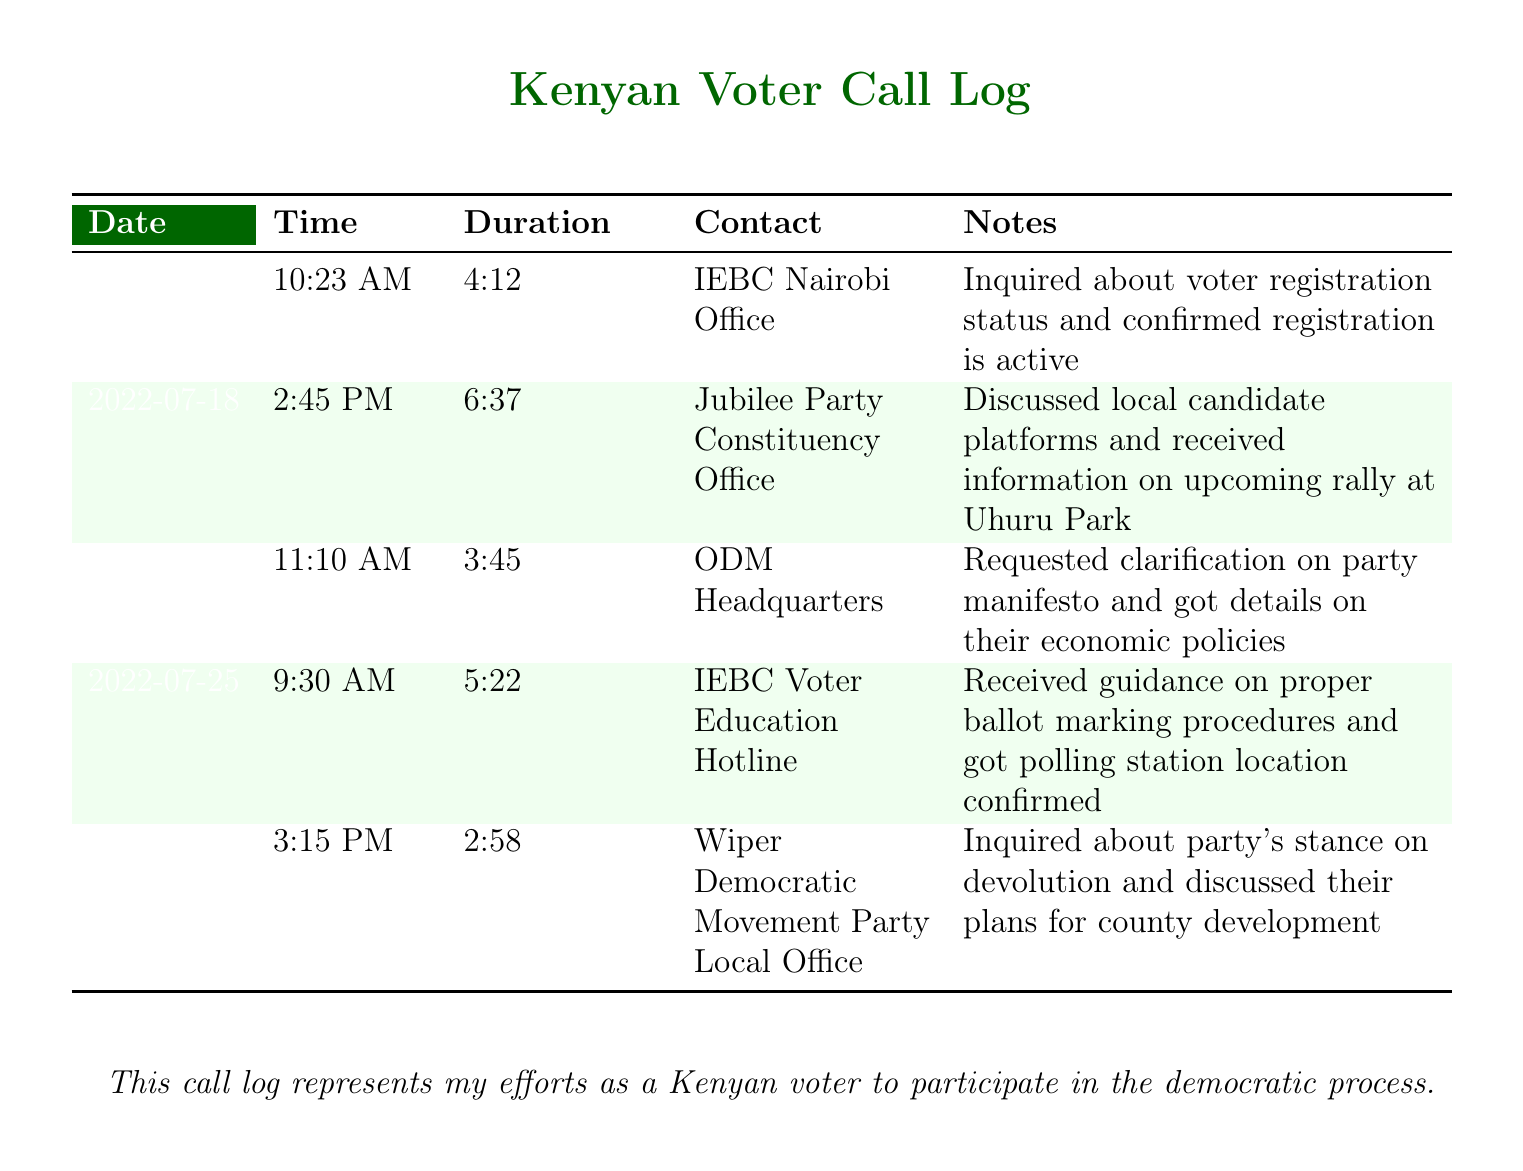what is the duration of the call on July 18? The duration is listed directly in the call log for that date at 2:45 PM.
Answer: 6:37 who did I call on July 22? The contact name is provided in the log entry for that date.
Answer: ODM Headquarters what information was received during the call to the IEBC Voter Education Hotline? The notes specify the type of information received during this call.
Answer: guidance on proper ballot marking procedures and polling station location confirmed how many total calls are recorded in the log? The total number can be determined by counting the rows in the table.
Answer: 5 what was inquired about during the call to the Wiper Democratic Movement Party Local Office? The notes describe the topic of inquiry in that entry.
Answer: party's stance on devolution what action was taken in the call with the Jubilee Party Constituency Office? The notes indicate the discussion held during the call.
Answer: discussed local candidate platforms and received information on upcoming rally at Uhuru Park 